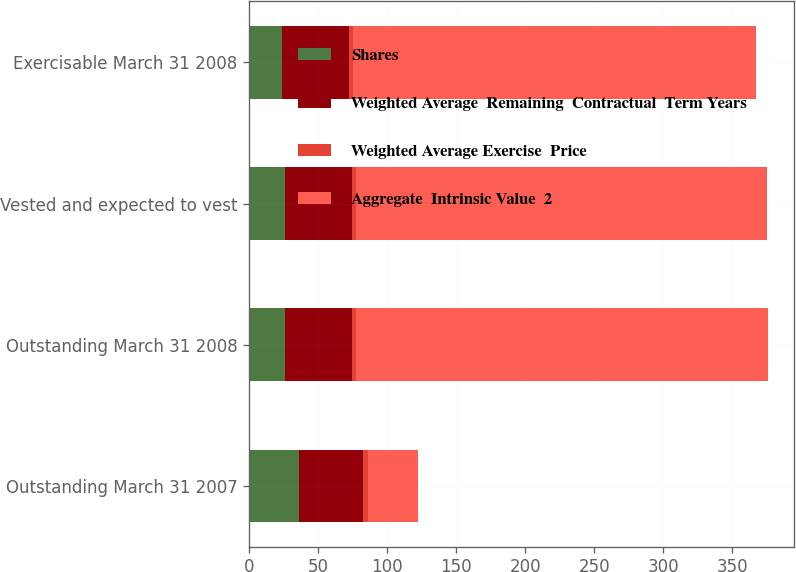Convert chart to OTSL. <chart><loc_0><loc_0><loc_500><loc_500><stacked_bar_chart><ecel><fcel>Outstanding March 31 2007<fcel>Outstanding March 31 2008<fcel>Vested and expected to vest<fcel>Exercisable March 31 2008<nl><fcel>Shares<fcel>36<fcel>26<fcel>26<fcel>24<nl><fcel>Weighted Average  Remaining  Contractual  Term Years<fcel>46.32<fcel>48.59<fcel>48.27<fcel>48.1<nl><fcel>Weighted Average Exercise  Price<fcel>4<fcel>3<fcel>3<fcel>3<nl><fcel>Aggregate  Intrinsic Value  2<fcel>36<fcel>298<fcel>298<fcel>292<nl></chart> 